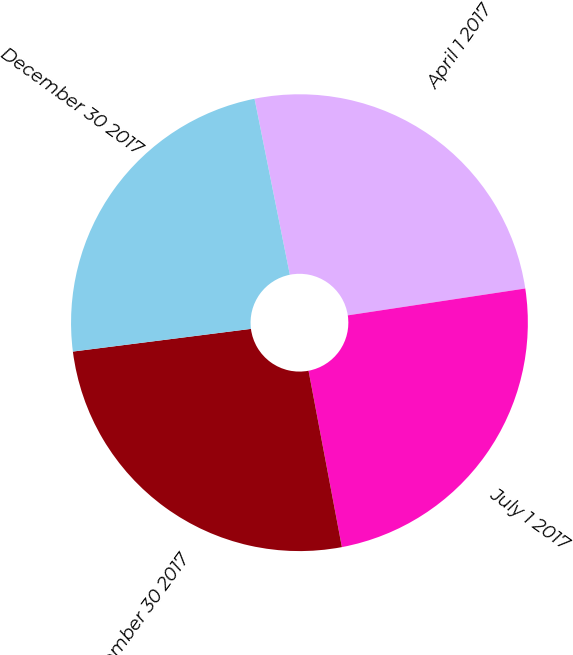Convert chart to OTSL. <chart><loc_0><loc_0><loc_500><loc_500><pie_chart><fcel>April 1 2017<fcel>July 1 2017<fcel>September 30 2017<fcel>December 30 2017<nl><fcel>25.76%<fcel>24.42%<fcel>25.96%<fcel>23.87%<nl></chart> 